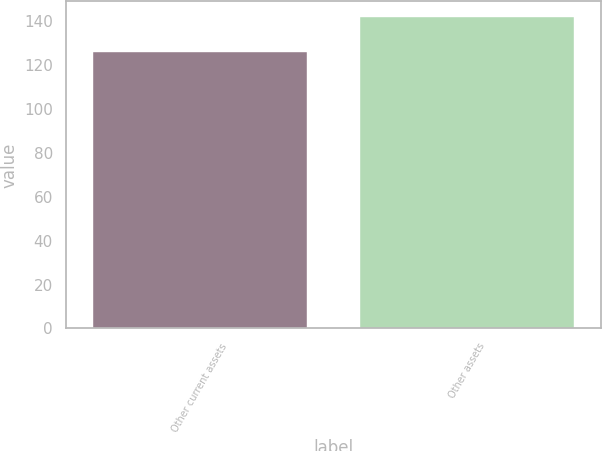<chart> <loc_0><loc_0><loc_500><loc_500><bar_chart><fcel>Other current assets<fcel>Other assets<nl><fcel>126<fcel>142<nl></chart> 